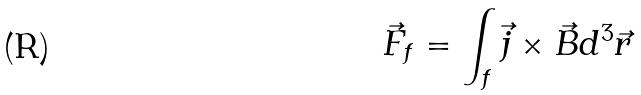<formula> <loc_0><loc_0><loc_500><loc_500>\vec { F } _ { f } = \int _ { f } \vec { j } \times \vec { B } d ^ { 3 } \vec { r }</formula> 